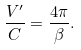Convert formula to latex. <formula><loc_0><loc_0><loc_500><loc_500>\frac { V ^ { \prime } } { C } = \frac { 4 \pi } { \beta } .</formula> 